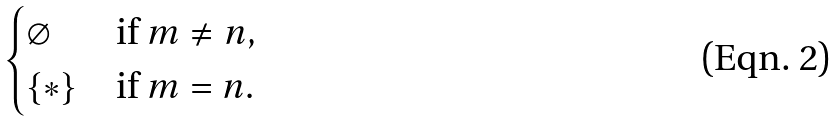Convert formula to latex. <formula><loc_0><loc_0><loc_500><loc_500>\begin{cases} \varnothing & \text {if } m \not = n , \\ \{ * \} & \text {if } m = n . \end{cases}</formula> 